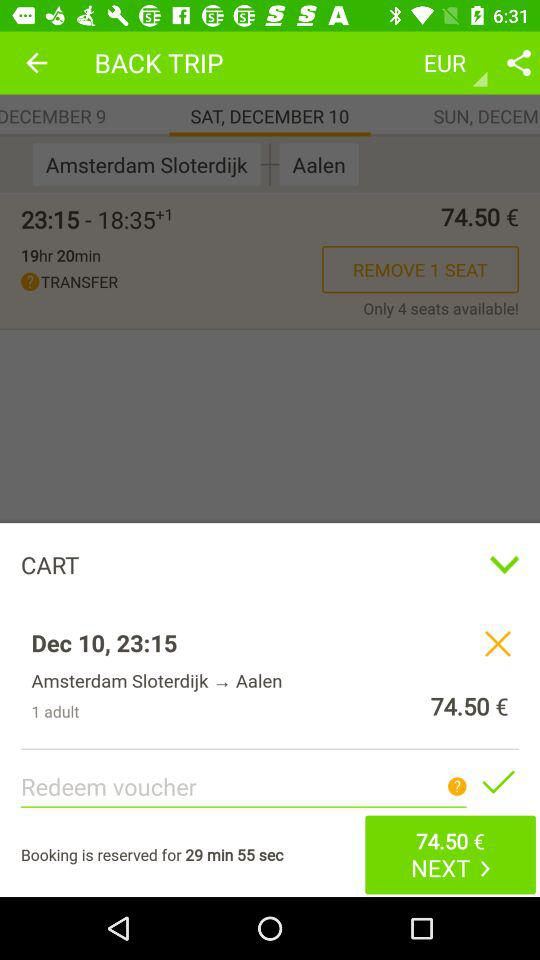How many minutes are left until the booking expires?
Answer the question using a single word or phrase. 29 min 55 sec 